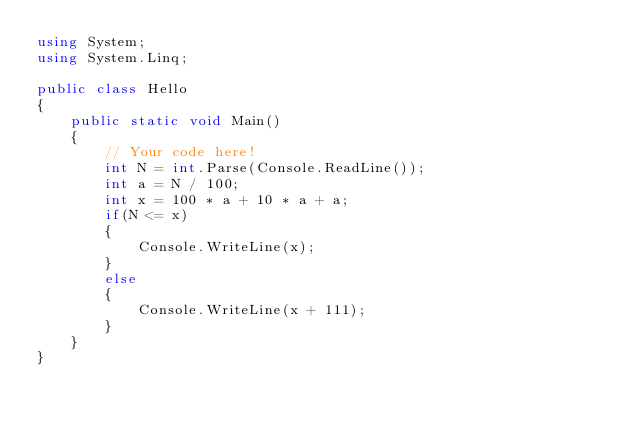<code> <loc_0><loc_0><loc_500><loc_500><_C#_>using System;
using System.Linq;

public class Hello
{
    public static void Main()
    {
        // Your code here!
        int N = int.Parse(Console.ReadLine());
        int a = N / 100;
        int x = 100 * a + 10 * a + a;
        if(N <= x)
        {
            Console.WriteLine(x);
        }
        else
        {
            Console.WriteLine(x + 111);
        }
    }
}</code> 